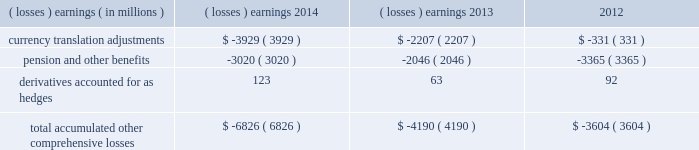Note 17 .
Accumulated other comprehensive losses : pmi's accumulated other comprehensive losses , net of taxes , consisted of the following: .
Reclassifications from other comprehensive earnings the movements in accumulated other comprehensive losses and the related tax impact , for each of the components above , that are due to current period activity and reclassifications to the income statement are shown on the consolidated statements of comprehensive earnings for the years ended december 31 , 2014 , 2013 , and 2012 .
The movement in currency translation adjustments for the year ended december 31 , 2013 , was also impacted by the purchase of the remaining shares of the mexican tobacco business .
In addition , $ 5 million and $ 12 million of net currency translation adjustment gains were transferred from other comprehensive earnings to marketing , administration and research costs in the consolidated statements of earnings for the years ended december 31 , 2014 and 2013 , respectively , upon liquidation of a subsidiary .
For additional information , see note 13 .
Benefit plans and note 15 .
Financial instruments for disclosures related to pmi's pension and other benefits and derivative financial instruments .
Note 18 .
Colombian investment and cooperation agreement : on june 19 , 2009 , pmi announced that it had signed an agreement with the republic of colombia , together with the departments of colombia and the capital district of bogota , to promote investment and cooperation with respect to the colombian tobacco market and to fight counterfeit and contraband tobacco products .
The investment and cooperation agreement provides $ 200 million in funding to the colombian governments over a 20-year period to address issues of mutual interest , such as combating the illegal cigarette trade , including the threat of counterfeit tobacco products , and increasing the quality and quantity of locally grown tobacco .
As a result of the investment and cooperation agreement , pmi recorded a pre-tax charge of $ 135 million in the operating results of the latin america & canada segment during the second quarter of 2009 .
At december 31 , 2014 and 2013 , pmi had $ 71 million and $ 74 million , respectively , of discounted liabilities associated with the colombian investment and cooperation agreement .
These discounted liabilities are primarily reflected in other long-term liabilities on the consolidated balance sheets and are expected to be paid through 2028 .
Note 19 .
Rbh legal settlement : on july 31 , 2008 , rothmans inc .
( "rothmans" ) announced the finalization of a cad 550 million settlement ( or approximately $ 540 million , based on the prevailing exchange rate at that time ) between itself and rothmans , benson & hedges inc .
( "rbh" ) , on the one hand , and the government of canada and all 10 provinces , on the other hand .
The settlement resolved the royal canadian mounted police's investigation relating to products exported from canada by rbh during the 1989-1996 period .
Rothmans' sole holding was a 60% ( 60 % ) interest in rbh .
The remaining 40% ( 40 % ) interest in rbh was owned by pmi. .
What portion of the total accumulated other comprehensive losses is incurred by the currency translation adjustments in 2014? 
Computations: (3929 / 6826)
Answer: 0.57559. 